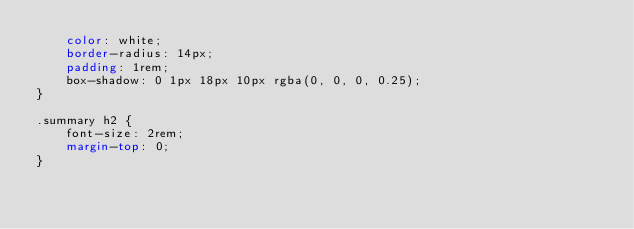<code> <loc_0><loc_0><loc_500><loc_500><_CSS_>    color: white;
    border-radius: 14px;
    padding: 1rem;
    box-shadow: 0 1px 18px 10px rgba(0, 0, 0, 0.25);
}

.summary h2 {
    font-size: 2rem;
    margin-top: 0;
}
</code> 